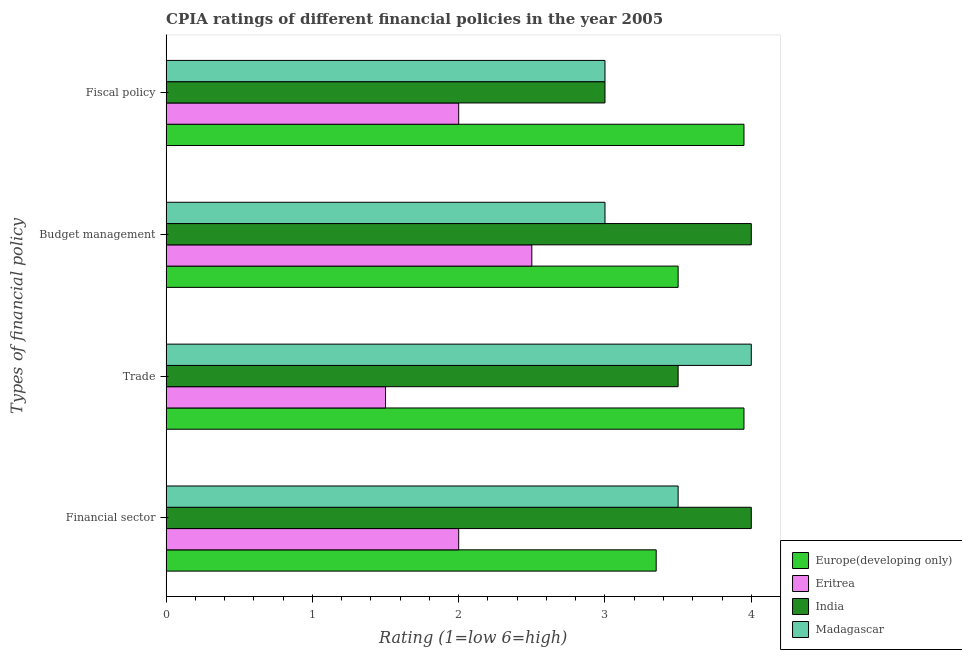How many groups of bars are there?
Provide a succinct answer. 4. Are the number of bars per tick equal to the number of legend labels?
Your response must be concise. Yes. Are the number of bars on each tick of the Y-axis equal?
Offer a very short reply. Yes. What is the label of the 2nd group of bars from the top?
Offer a very short reply. Budget management. In which country was the cpia rating of trade minimum?
Ensure brevity in your answer.  Eritrea. What is the total cpia rating of fiscal policy in the graph?
Your answer should be very brief. 11.95. What is the difference between the cpia rating of fiscal policy in Europe(developing only) and that in Eritrea?
Your response must be concise. 1.95. What is the difference between the cpia rating of financial sector in India and the cpia rating of trade in Europe(developing only)?
Keep it short and to the point. 0.05. What is the average cpia rating of fiscal policy per country?
Make the answer very short. 2.99. What is the difference between the cpia rating of trade and cpia rating of fiscal policy in Europe(developing only)?
Ensure brevity in your answer.  0. In how many countries, is the cpia rating of budget management greater than 3.6 ?
Offer a very short reply. 1. What is the ratio of the cpia rating of budget management in India to that in Eritrea?
Provide a short and direct response. 1.6. Is the cpia rating of trade in Eritrea less than that in India?
Ensure brevity in your answer.  Yes. What is the difference between the highest and the second highest cpia rating of fiscal policy?
Provide a succinct answer. 0.95. What is the difference between the highest and the lowest cpia rating of budget management?
Ensure brevity in your answer.  1.5. In how many countries, is the cpia rating of budget management greater than the average cpia rating of budget management taken over all countries?
Ensure brevity in your answer.  2. Is the sum of the cpia rating of fiscal policy in Madagascar and India greater than the maximum cpia rating of trade across all countries?
Offer a terse response. Yes. Is it the case that in every country, the sum of the cpia rating of financial sector and cpia rating of trade is greater than the sum of cpia rating of fiscal policy and cpia rating of budget management?
Give a very brief answer. No. What does the 1st bar from the top in Fiscal policy represents?
Provide a succinct answer. Madagascar. What does the 4th bar from the bottom in Financial sector represents?
Keep it short and to the point. Madagascar. How many bars are there?
Make the answer very short. 16. Are all the bars in the graph horizontal?
Offer a very short reply. Yes. What is the difference between two consecutive major ticks on the X-axis?
Offer a very short reply. 1. Does the graph contain grids?
Your response must be concise. No. How many legend labels are there?
Your answer should be very brief. 4. What is the title of the graph?
Your answer should be very brief. CPIA ratings of different financial policies in the year 2005. What is the label or title of the X-axis?
Give a very brief answer. Rating (1=low 6=high). What is the label or title of the Y-axis?
Provide a short and direct response. Types of financial policy. What is the Rating (1=low 6=high) of Europe(developing only) in Financial sector?
Offer a terse response. 3.35. What is the Rating (1=low 6=high) in Europe(developing only) in Trade?
Your answer should be very brief. 3.95. What is the Rating (1=low 6=high) in India in Trade?
Your answer should be very brief. 3.5. What is the Rating (1=low 6=high) in Europe(developing only) in Budget management?
Your answer should be compact. 3.5. What is the Rating (1=low 6=high) in Eritrea in Budget management?
Give a very brief answer. 2.5. What is the Rating (1=low 6=high) in Madagascar in Budget management?
Keep it short and to the point. 3. What is the Rating (1=low 6=high) of Europe(developing only) in Fiscal policy?
Keep it short and to the point. 3.95. What is the Rating (1=low 6=high) in Eritrea in Fiscal policy?
Ensure brevity in your answer.  2. Across all Types of financial policy, what is the maximum Rating (1=low 6=high) in Europe(developing only)?
Ensure brevity in your answer.  3.95. Across all Types of financial policy, what is the maximum Rating (1=low 6=high) of Eritrea?
Your answer should be very brief. 2.5. Across all Types of financial policy, what is the minimum Rating (1=low 6=high) of Europe(developing only)?
Keep it short and to the point. 3.35. Across all Types of financial policy, what is the minimum Rating (1=low 6=high) in Eritrea?
Make the answer very short. 1.5. What is the total Rating (1=low 6=high) of Europe(developing only) in the graph?
Give a very brief answer. 14.75. What is the total Rating (1=low 6=high) of Eritrea in the graph?
Provide a short and direct response. 8. What is the total Rating (1=low 6=high) in India in the graph?
Provide a short and direct response. 14.5. What is the difference between the Rating (1=low 6=high) of Europe(developing only) in Financial sector and that in Trade?
Your answer should be very brief. -0.6. What is the difference between the Rating (1=low 6=high) of Eritrea in Financial sector and that in Trade?
Give a very brief answer. 0.5. What is the difference between the Rating (1=low 6=high) of Europe(developing only) in Financial sector and that in Budget management?
Your answer should be compact. -0.15. What is the difference between the Rating (1=low 6=high) in Eritrea in Financial sector and that in Budget management?
Your response must be concise. -0.5. What is the difference between the Rating (1=low 6=high) of India in Financial sector and that in Budget management?
Ensure brevity in your answer.  0. What is the difference between the Rating (1=low 6=high) of Madagascar in Financial sector and that in Budget management?
Make the answer very short. 0.5. What is the difference between the Rating (1=low 6=high) in India in Financial sector and that in Fiscal policy?
Make the answer very short. 1. What is the difference between the Rating (1=low 6=high) of Europe(developing only) in Trade and that in Budget management?
Give a very brief answer. 0.45. What is the difference between the Rating (1=low 6=high) of Madagascar in Trade and that in Budget management?
Ensure brevity in your answer.  1. What is the difference between the Rating (1=low 6=high) in India in Trade and that in Fiscal policy?
Provide a short and direct response. 0.5. What is the difference between the Rating (1=low 6=high) in Madagascar in Trade and that in Fiscal policy?
Your answer should be very brief. 1. What is the difference between the Rating (1=low 6=high) in Europe(developing only) in Budget management and that in Fiscal policy?
Your answer should be compact. -0.45. What is the difference between the Rating (1=low 6=high) of Eritrea in Budget management and that in Fiscal policy?
Keep it short and to the point. 0.5. What is the difference between the Rating (1=low 6=high) of Madagascar in Budget management and that in Fiscal policy?
Offer a very short reply. 0. What is the difference between the Rating (1=low 6=high) in Europe(developing only) in Financial sector and the Rating (1=low 6=high) in Eritrea in Trade?
Make the answer very short. 1.85. What is the difference between the Rating (1=low 6=high) in Europe(developing only) in Financial sector and the Rating (1=low 6=high) in Madagascar in Trade?
Provide a short and direct response. -0.65. What is the difference between the Rating (1=low 6=high) in Eritrea in Financial sector and the Rating (1=low 6=high) in India in Trade?
Offer a terse response. -1.5. What is the difference between the Rating (1=low 6=high) of Eritrea in Financial sector and the Rating (1=low 6=high) of Madagascar in Trade?
Make the answer very short. -2. What is the difference between the Rating (1=low 6=high) in Europe(developing only) in Financial sector and the Rating (1=low 6=high) in Eritrea in Budget management?
Offer a very short reply. 0.85. What is the difference between the Rating (1=low 6=high) of Europe(developing only) in Financial sector and the Rating (1=low 6=high) of India in Budget management?
Give a very brief answer. -0.65. What is the difference between the Rating (1=low 6=high) of Europe(developing only) in Financial sector and the Rating (1=low 6=high) of Madagascar in Budget management?
Ensure brevity in your answer.  0.35. What is the difference between the Rating (1=low 6=high) of Eritrea in Financial sector and the Rating (1=low 6=high) of India in Budget management?
Provide a short and direct response. -2. What is the difference between the Rating (1=low 6=high) of Eritrea in Financial sector and the Rating (1=low 6=high) of Madagascar in Budget management?
Your response must be concise. -1. What is the difference between the Rating (1=low 6=high) of Europe(developing only) in Financial sector and the Rating (1=low 6=high) of Eritrea in Fiscal policy?
Provide a short and direct response. 1.35. What is the difference between the Rating (1=low 6=high) of Europe(developing only) in Financial sector and the Rating (1=low 6=high) of Madagascar in Fiscal policy?
Your response must be concise. 0.35. What is the difference between the Rating (1=low 6=high) in Europe(developing only) in Trade and the Rating (1=low 6=high) in Eritrea in Budget management?
Your response must be concise. 1.45. What is the difference between the Rating (1=low 6=high) of Europe(developing only) in Trade and the Rating (1=low 6=high) of India in Budget management?
Keep it short and to the point. -0.05. What is the difference between the Rating (1=low 6=high) of India in Trade and the Rating (1=low 6=high) of Madagascar in Budget management?
Offer a terse response. 0.5. What is the difference between the Rating (1=low 6=high) of Europe(developing only) in Trade and the Rating (1=low 6=high) of Eritrea in Fiscal policy?
Keep it short and to the point. 1.95. What is the difference between the Rating (1=low 6=high) of Europe(developing only) in Trade and the Rating (1=low 6=high) of India in Fiscal policy?
Make the answer very short. 0.95. What is the difference between the Rating (1=low 6=high) in Europe(developing only) in Trade and the Rating (1=low 6=high) in Madagascar in Fiscal policy?
Ensure brevity in your answer.  0.95. What is the difference between the Rating (1=low 6=high) in Eritrea in Trade and the Rating (1=low 6=high) in India in Fiscal policy?
Offer a very short reply. -1.5. What is the difference between the Rating (1=low 6=high) of India in Trade and the Rating (1=low 6=high) of Madagascar in Fiscal policy?
Offer a terse response. 0.5. What is the difference between the Rating (1=low 6=high) in Eritrea in Budget management and the Rating (1=low 6=high) in Madagascar in Fiscal policy?
Provide a succinct answer. -0.5. What is the average Rating (1=low 6=high) in Europe(developing only) per Types of financial policy?
Your answer should be compact. 3.69. What is the average Rating (1=low 6=high) of Eritrea per Types of financial policy?
Provide a succinct answer. 2. What is the average Rating (1=low 6=high) in India per Types of financial policy?
Your answer should be compact. 3.62. What is the average Rating (1=low 6=high) of Madagascar per Types of financial policy?
Make the answer very short. 3.38. What is the difference between the Rating (1=low 6=high) of Europe(developing only) and Rating (1=low 6=high) of Eritrea in Financial sector?
Provide a short and direct response. 1.35. What is the difference between the Rating (1=low 6=high) in Europe(developing only) and Rating (1=low 6=high) in India in Financial sector?
Provide a short and direct response. -0.65. What is the difference between the Rating (1=low 6=high) of Eritrea and Rating (1=low 6=high) of India in Financial sector?
Make the answer very short. -2. What is the difference between the Rating (1=low 6=high) of India and Rating (1=low 6=high) of Madagascar in Financial sector?
Your answer should be compact. 0.5. What is the difference between the Rating (1=low 6=high) of Europe(developing only) and Rating (1=low 6=high) of Eritrea in Trade?
Offer a very short reply. 2.45. What is the difference between the Rating (1=low 6=high) in Europe(developing only) and Rating (1=low 6=high) in India in Trade?
Ensure brevity in your answer.  0.45. What is the difference between the Rating (1=low 6=high) of Europe(developing only) and Rating (1=low 6=high) of Madagascar in Trade?
Give a very brief answer. -0.05. What is the difference between the Rating (1=low 6=high) in Eritrea and Rating (1=low 6=high) in India in Trade?
Give a very brief answer. -2. What is the difference between the Rating (1=low 6=high) in India and Rating (1=low 6=high) in Madagascar in Trade?
Keep it short and to the point. -0.5. What is the difference between the Rating (1=low 6=high) of Europe(developing only) and Rating (1=low 6=high) of Eritrea in Budget management?
Offer a terse response. 1. What is the difference between the Rating (1=low 6=high) of Europe(developing only) and Rating (1=low 6=high) of India in Budget management?
Make the answer very short. -0.5. What is the difference between the Rating (1=low 6=high) of Europe(developing only) and Rating (1=low 6=high) of Madagascar in Budget management?
Provide a succinct answer. 0.5. What is the difference between the Rating (1=low 6=high) of Eritrea and Rating (1=low 6=high) of India in Budget management?
Offer a terse response. -1.5. What is the difference between the Rating (1=low 6=high) of India and Rating (1=low 6=high) of Madagascar in Budget management?
Offer a terse response. 1. What is the difference between the Rating (1=low 6=high) of Europe(developing only) and Rating (1=low 6=high) of Eritrea in Fiscal policy?
Keep it short and to the point. 1.95. What is the difference between the Rating (1=low 6=high) of Europe(developing only) and Rating (1=low 6=high) of India in Fiscal policy?
Give a very brief answer. 0.95. What is the difference between the Rating (1=low 6=high) in Europe(developing only) and Rating (1=low 6=high) in Madagascar in Fiscal policy?
Your response must be concise. 0.95. What is the difference between the Rating (1=low 6=high) in India and Rating (1=low 6=high) in Madagascar in Fiscal policy?
Offer a terse response. 0. What is the ratio of the Rating (1=low 6=high) in Europe(developing only) in Financial sector to that in Trade?
Make the answer very short. 0.85. What is the ratio of the Rating (1=low 6=high) in India in Financial sector to that in Trade?
Your answer should be very brief. 1.14. What is the ratio of the Rating (1=low 6=high) of Madagascar in Financial sector to that in Trade?
Keep it short and to the point. 0.88. What is the ratio of the Rating (1=low 6=high) in Europe(developing only) in Financial sector to that in Budget management?
Keep it short and to the point. 0.96. What is the ratio of the Rating (1=low 6=high) in Eritrea in Financial sector to that in Budget management?
Your answer should be very brief. 0.8. What is the ratio of the Rating (1=low 6=high) in Europe(developing only) in Financial sector to that in Fiscal policy?
Give a very brief answer. 0.85. What is the ratio of the Rating (1=low 6=high) of Eritrea in Financial sector to that in Fiscal policy?
Provide a short and direct response. 1. What is the ratio of the Rating (1=low 6=high) of Europe(developing only) in Trade to that in Budget management?
Give a very brief answer. 1.13. What is the ratio of the Rating (1=low 6=high) of Eritrea in Trade to that in Budget management?
Make the answer very short. 0.6. What is the ratio of the Rating (1=low 6=high) in India in Trade to that in Fiscal policy?
Your response must be concise. 1.17. What is the ratio of the Rating (1=low 6=high) of Madagascar in Trade to that in Fiscal policy?
Offer a very short reply. 1.33. What is the ratio of the Rating (1=low 6=high) of Europe(developing only) in Budget management to that in Fiscal policy?
Your answer should be compact. 0.89. What is the ratio of the Rating (1=low 6=high) of Madagascar in Budget management to that in Fiscal policy?
Offer a very short reply. 1. What is the difference between the highest and the second highest Rating (1=low 6=high) in Europe(developing only)?
Offer a very short reply. 0. What is the difference between the highest and the second highest Rating (1=low 6=high) of India?
Your response must be concise. 0. What is the difference between the highest and the lowest Rating (1=low 6=high) in Europe(developing only)?
Your answer should be compact. 0.6. What is the difference between the highest and the lowest Rating (1=low 6=high) in Eritrea?
Keep it short and to the point. 1. What is the difference between the highest and the lowest Rating (1=low 6=high) of Madagascar?
Provide a short and direct response. 1. 